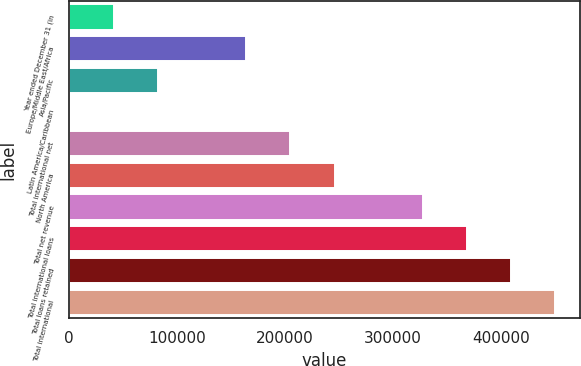Convert chart to OTSL. <chart><loc_0><loc_0><loc_500><loc_500><bar_chart><fcel>Year ended December 31 (in<fcel>Europe/Middle East/Africa<fcel>Asia/Pacific<fcel>Latin America/Caribbean<fcel>Total international net<fcel>North America<fcel>Total net revenue<fcel>Total international loans<fcel>Total loans retained<fcel>Total international<nl><fcel>41903.6<fcel>164239<fcel>82682.2<fcel>1125<fcel>205018<fcel>245797<fcel>327354<fcel>368132<fcel>408911<fcel>449690<nl></chart> 